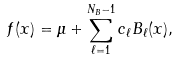Convert formula to latex. <formula><loc_0><loc_0><loc_500><loc_500>f ( x ) = \mu + \sum _ { \ell = 1 } ^ { N _ { B } - 1 } c _ { \ell } B _ { \ell } ( x ) ,</formula> 